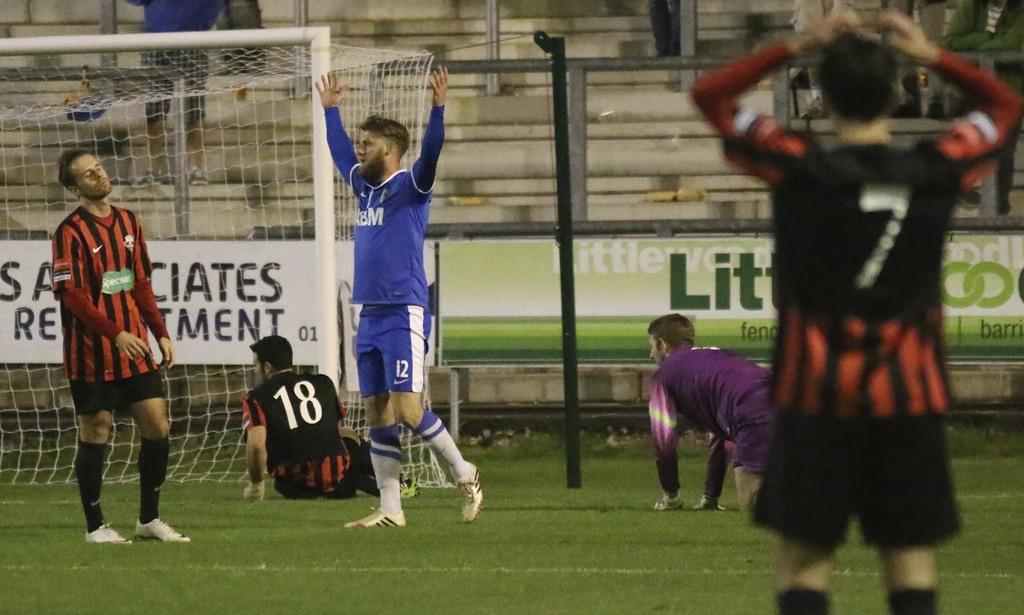Who or what is present in the image? There are people in the image. What are the people wearing? The people are wearing clothes. What can be seen on the left side of the image? There is a goal post on the left side of the image. What is located in the middle of the image? There is a pole and a board in the middle of the image. What type of temper can be seen in the people in the image? There is no indication of the people's temper in the image. How many clams are present on the board in the image? There are no clams present in the image; the board is not related to clams. 